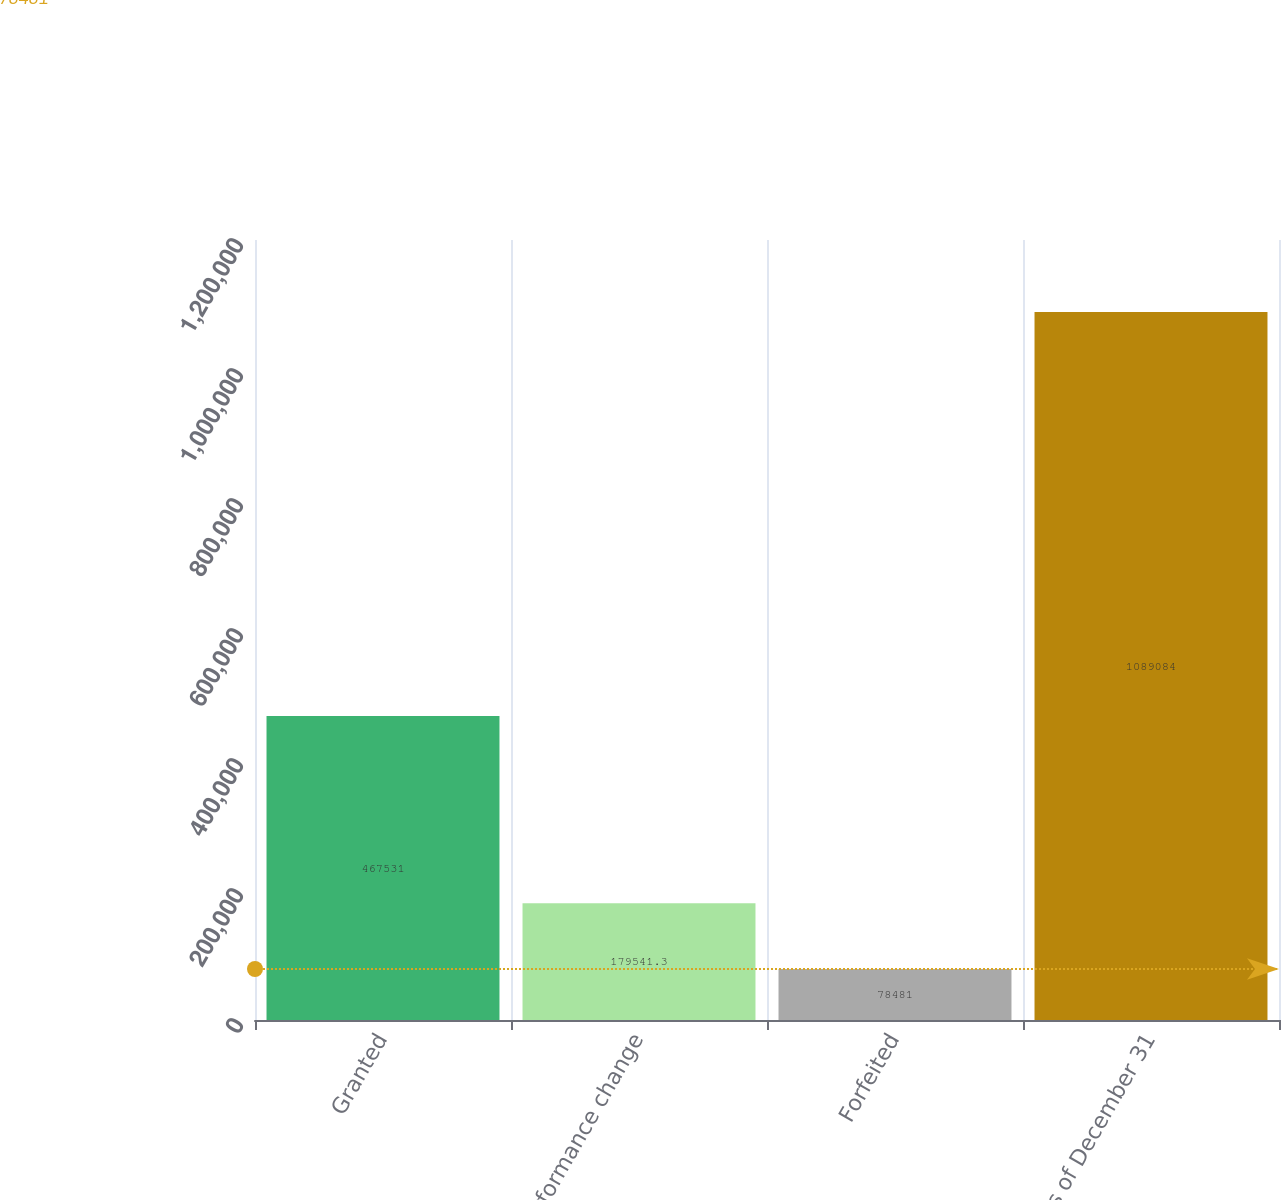<chart> <loc_0><loc_0><loc_500><loc_500><bar_chart><fcel>Granted<fcel>Performance change<fcel>Forfeited<fcel>As of December 31<nl><fcel>467531<fcel>179541<fcel>78481<fcel>1.08908e+06<nl></chart> 